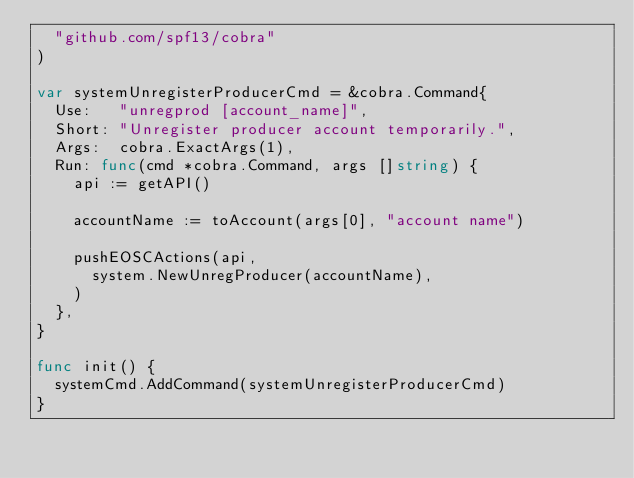<code> <loc_0><loc_0><loc_500><loc_500><_Go_>	"github.com/spf13/cobra"
)

var systemUnregisterProducerCmd = &cobra.Command{
	Use:   "unregprod [account_name]",
	Short: "Unregister producer account temporarily.",
	Args:  cobra.ExactArgs(1),
	Run: func(cmd *cobra.Command, args []string) {
		api := getAPI()

		accountName := toAccount(args[0], "account name")

		pushEOSCActions(api,
			system.NewUnregProducer(accountName),
		)
	},
}

func init() {
	systemCmd.AddCommand(systemUnregisterProducerCmd)
}
</code> 